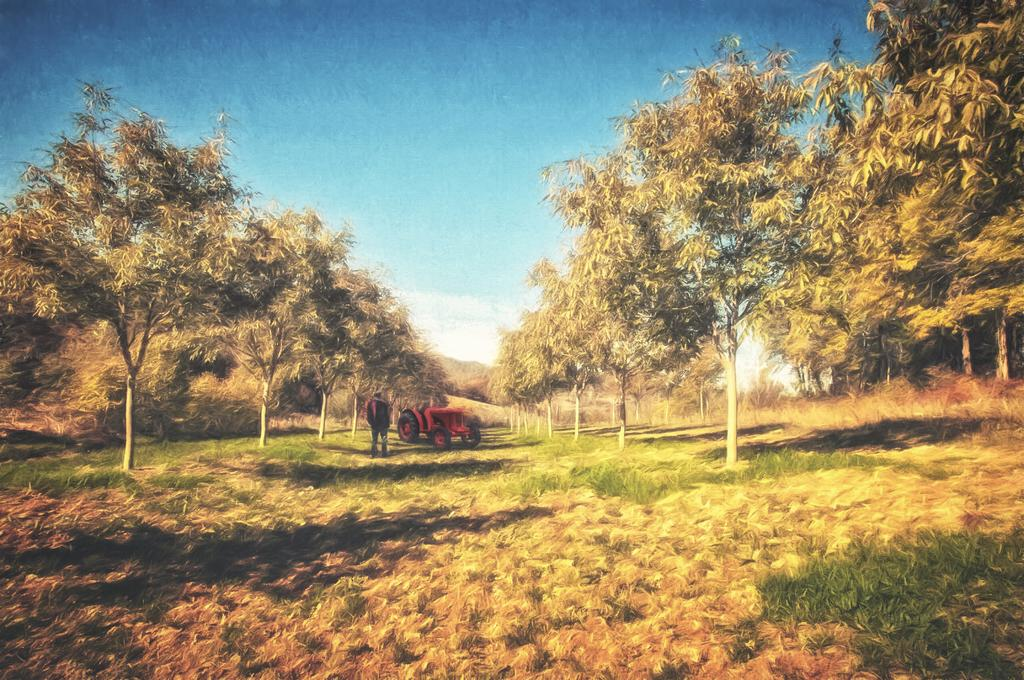What type of vegetation is present in the image? There is grass and trees in the image. What else can be seen in the image besides vegetation? There is a vehicle and a person standing on the ground in the image. What is visible in the background of the image? The sky is visible in the background of the image, and there are clouds in the sky. What type of fold can be seen in the person's apparel in the image? There is no fold visible in the person's apparel in the image, as the provided facts do not mention any specific details about the person's clothing. 